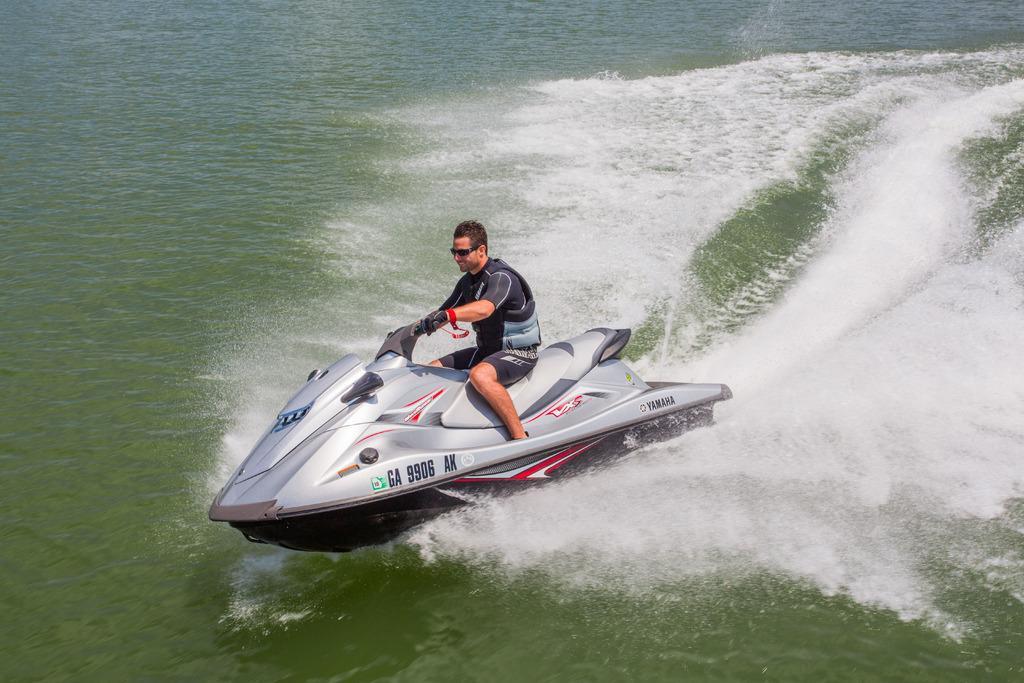Please provide a concise description of this image. In this image, we can see a man on the speedboat and we can see water. 